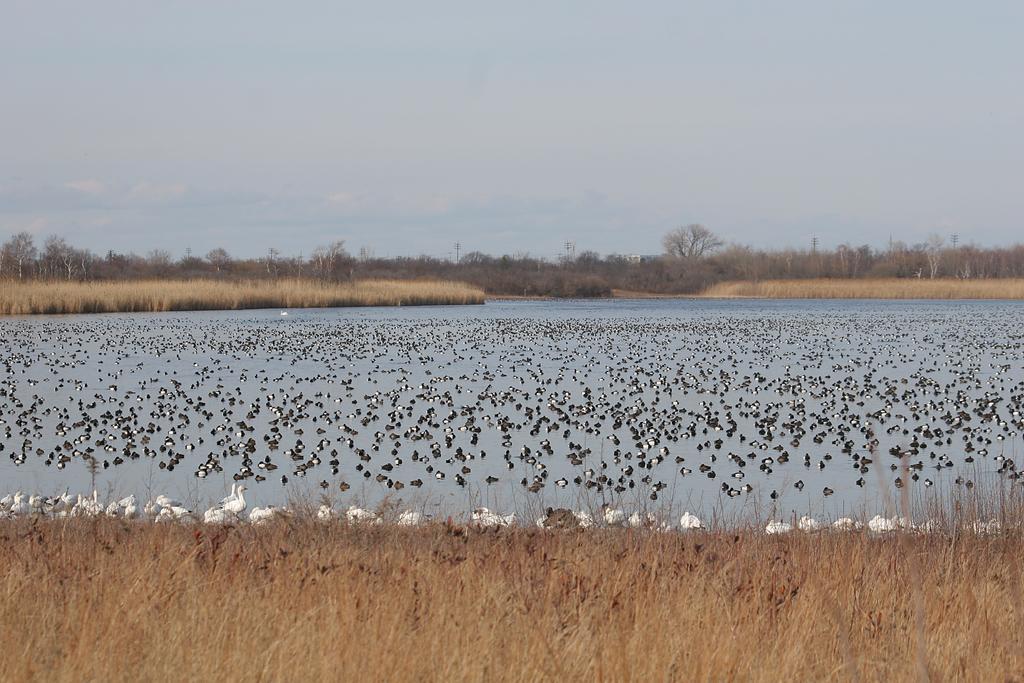Describe this image in one or two sentences. There is a big group of ducks are present on the surface of a water as we can see in the middle of this image. There are some trees in the background. There is a sky at the top of this image. There is a grassy land at the bottom of this image. 